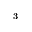Convert formula to latex. <formula><loc_0><loc_0><loc_500><loc_500>^ { 3 }</formula> 